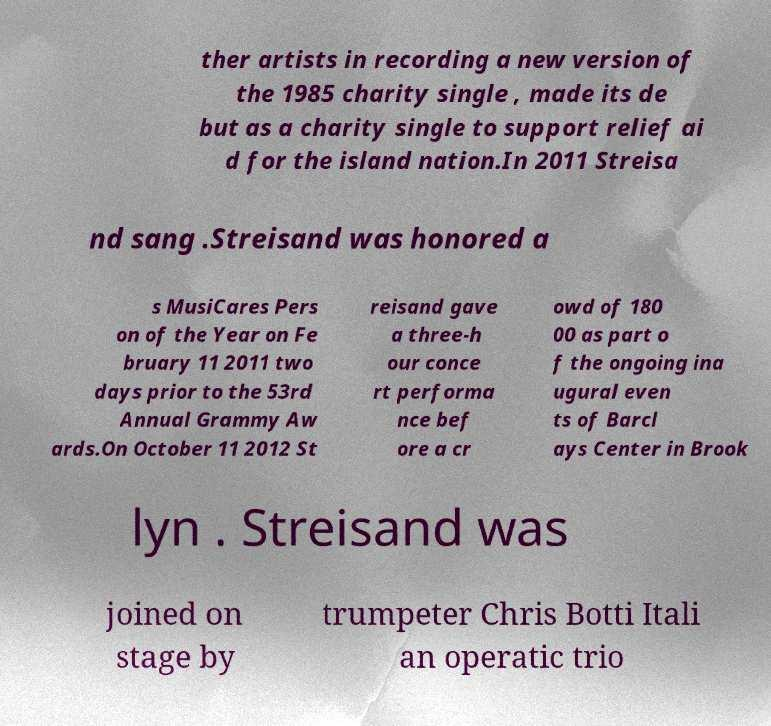Can you accurately transcribe the text from the provided image for me? ther artists in recording a new version of the 1985 charity single , made its de but as a charity single to support relief ai d for the island nation.In 2011 Streisa nd sang .Streisand was honored a s MusiCares Pers on of the Year on Fe bruary 11 2011 two days prior to the 53rd Annual Grammy Aw ards.On October 11 2012 St reisand gave a three-h our conce rt performa nce bef ore a cr owd of 180 00 as part o f the ongoing ina ugural even ts of Barcl ays Center in Brook lyn . Streisand was joined on stage by trumpeter Chris Botti Itali an operatic trio 